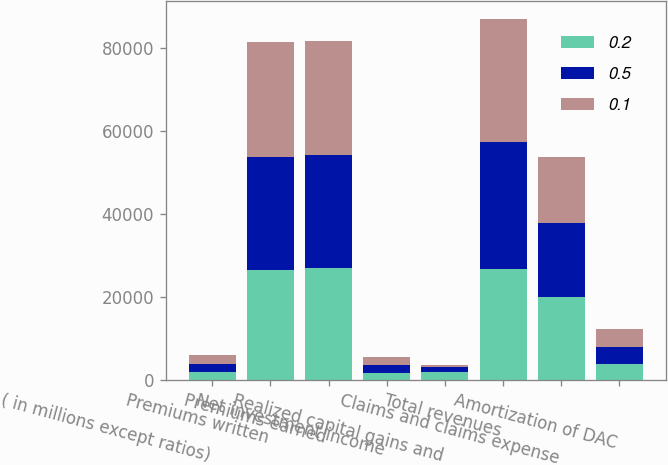Convert chart. <chart><loc_0><loc_0><loc_500><loc_500><stacked_bar_chart><ecel><fcel>( in millions except ratios)<fcel>Premiums written<fcel>Premiums earned<fcel>Net investment income<fcel>Realized capital gains and<fcel>Total revenues<fcel>Claims and claims expense<fcel>Amortization of DAC<nl><fcel>0.2<fcel>2008<fcel>26584<fcel>26967<fcel>1674<fcel>1858<fcel>26783<fcel>20064<fcel>3975<nl><fcel>0.5<fcel>2007<fcel>27183<fcel>27233<fcel>1972<fcel>1416<fcel>30621<fcel>17667<fcel>4121<nl><fcel>0.1<fcel>2006<fcel>27526<fcel>27369<fcel>1854<fcel>348<fcel>29571<fcel>16017<fcel>4131<nl></chart> 